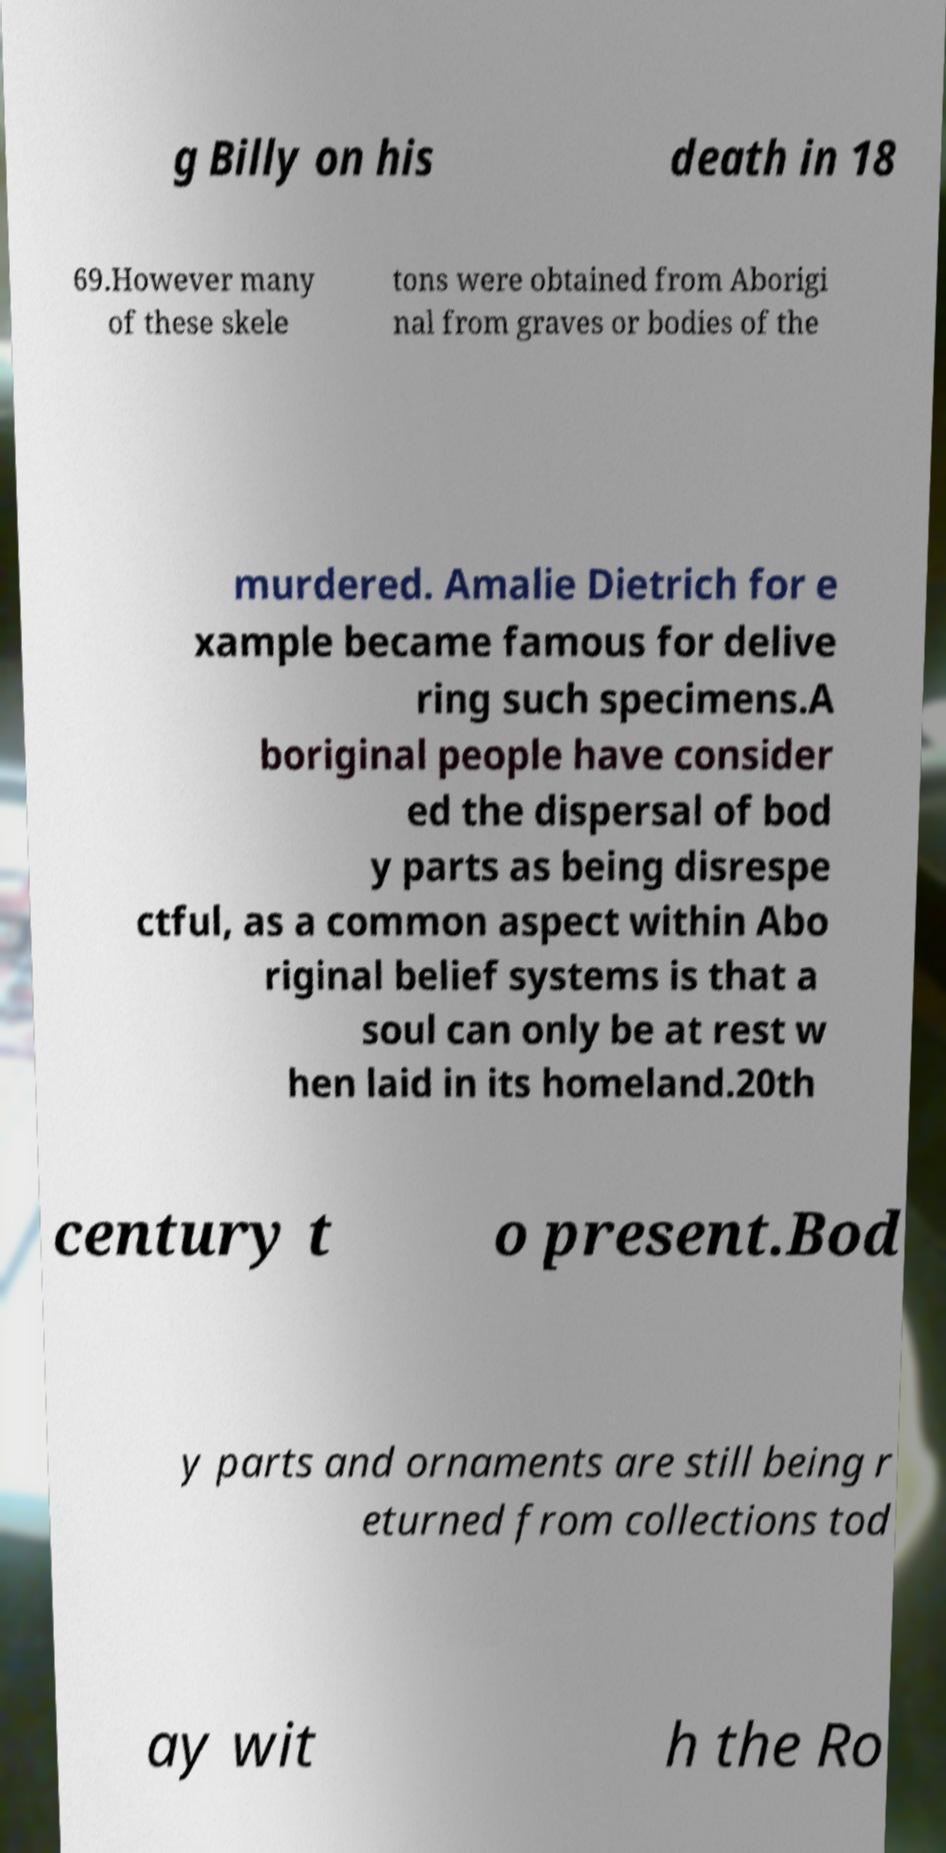For documentation purposes, I need the text within this image transcribed. Could you provide that? g Billy on his death in 18 69.However many of these skele tons were obtained from Aborigi nal from graves or bodies of the murdered. Amalie Dietrich for e xample became famous for delive ring such specimens.A boriginal people have consider ed the dispersal of bod y parts as being disrespe ctful, as a common aspect within Abo riginal belief systems is that a soul can only be at rest w hen laid in its homeland.20th century t o present.Bod y parts and ornaments are still being r eturned from collections tod ay wit h the Ro 